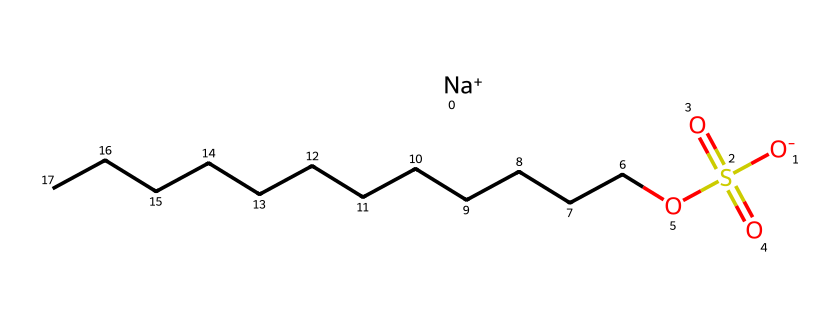What is the chemical name of this compound? The SMILES notation describes the compound, which includes sodium (Na) and dodecyl (12 carbon atoms in a straight chain), along with sulfonic acid functionalities. Thus, the full name based on the SMILES representation is sodium dodecyl sulfate.
Answer: sodium dodecyl sulfate How many carbon atoms are in the dodecyl chain? The structure shows a straight chain that contains 12 carbon (C) atoms in the dodecyl part, as indicated by the sequence of "CCCCCCCCCCCC" in the SMILES.
Answer: 12 What type of ion is present in this surfactant? The SMILES representation shows the presence of [Na+] which indicates that there is a sodium ion, a cation that balances the negatively charged sulfate group.
Answer: sodium ion How many sulfate groups are in this molecule? The structure contains one sulfate group (-SO4), represented by (S(=O)(=O)O), which indicates its presence along with the sodium and dodecyl part.
Answer: one What charge does the sulfate part of this compound have? Analyzing the SMILES, the sulfate group has a negative charge indicated by [O-] linked with the sulfur atom, meaning it carries a single negative charge.
Answer: negative Why is sodium dodecyl sulfate considered a surfactant? The presence of a long hydrophobic dodecyl chain and a hydrophilic sulfate group allows it to lower surface tension between liquids and facilitate the spreading and mixing of substances, thereby classifying it as a surfactant.
Answer: lowers surface tension 